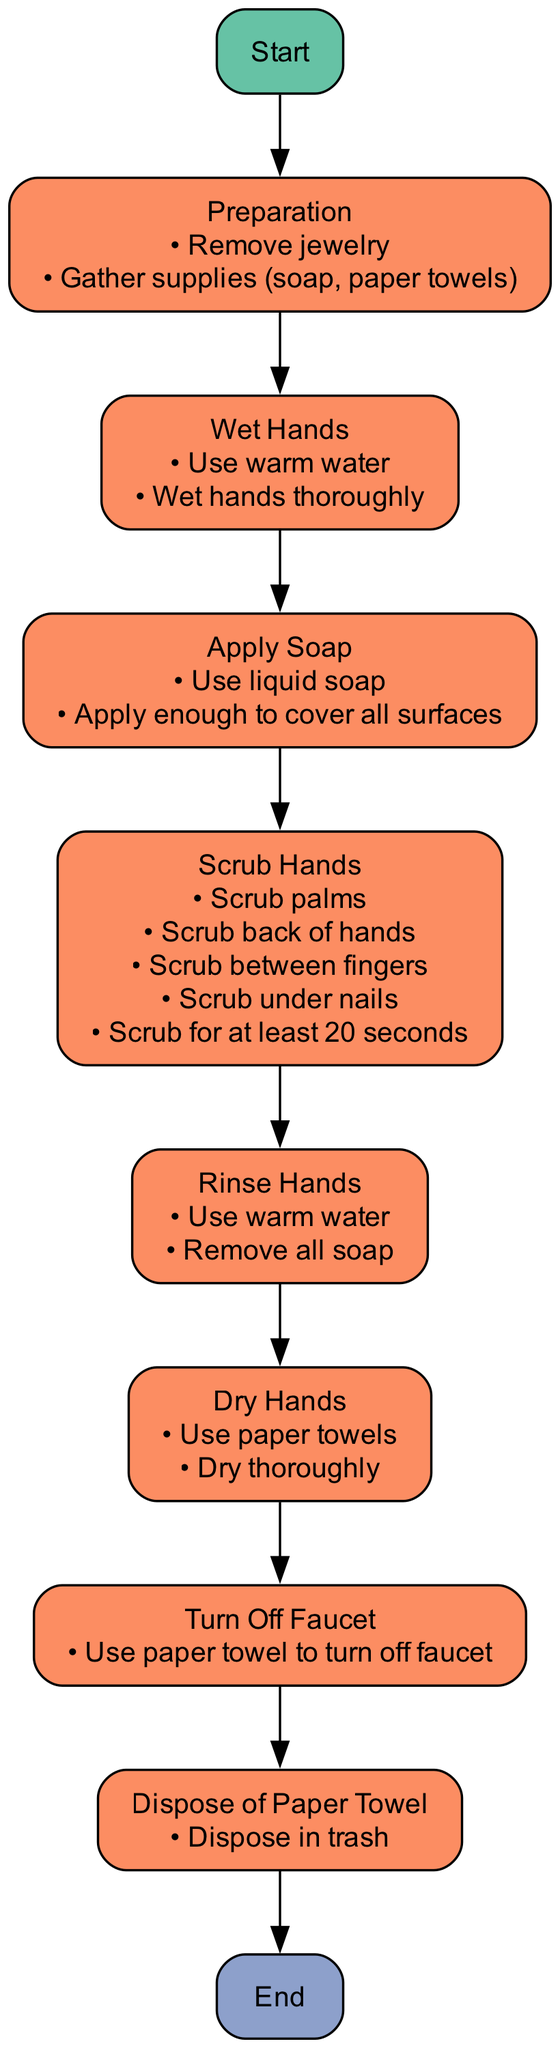What is the first step in the hand washing procedure? The diagram indicates that the first step in the hand washing procedure is "Preparation." This is shown at the beginning of the flow chart as the first node after "Start."
Answer: Preparation How many total processes are involved in the hand washing procedure? By counting the specific process nodes shown in the diagram, there are seven distinct processes listed: Preparation, Wet Hands, Apply Soap, Scrub Hands, Rinse Hands, Dry Hands, and Turn Off Faucet.
Answer: Seven What do servers need to remove before starting the hand washing procedure? According to the actions listed in the "Preparation" node, servers need to remove their jewelry before beginning the hand washing process.
Answer: Jewelry What is the minimum duration for scrubbing hands according to the procedure? In the "Scrub Hands" node, it explicitly states that hands must be scrubbed for at least 20 seconds, highlighting the importance of thorough cleaning.
Answer: 20 seconds What action should be taken after drying hands? The next step specified in the flow chart after "Dry Hands" is to "Turn Off Faucet," which is the immediate action following that process.
Answer: Turn Off Faucet What should be used to turn off the faucet after washing hands? The "Turn Off Faucet" node specifies that paper towels should be used to turn off the faucet, ensuring that hands remain clean after washing.
Answer: Paper towel Where should the paper towel be disposed of after use? The flow chart indicates that after using the paper towel, it should be disposed of in the trash, as described in the "Dispose of Paper Towel" node.
Answer: Trash What is the last step in the hand washing procedure? The last node in the sequence is labeled "End," indicating the conclusion of the hand washing procedure, following all prior steps.
Answer: End 